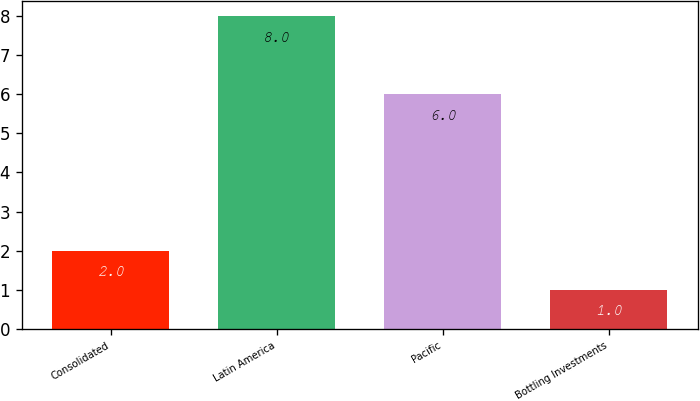Convert chart to OTSL. <chart><loc_0><loc_0><loc_500><loc_500><bar_chart><fcel>Consolidated<fcel>Latin America<fcel>Pacific<fcel>Bottling Investments<nl><fcel>2<fcel>8<fcel>6<fcel>1<nl></chart> 